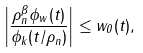Convert formula to latex. <formula><loc_0><loc_0><loc_500><loc_500>\left | \frac { \rho _ { n } ^ { \beta } \phi _ { w } ( t ) } { \phi _ { k } ( t / \rho _ { n } ) } \right | \leq w _ { 0 } ( t ) ,</formula> 